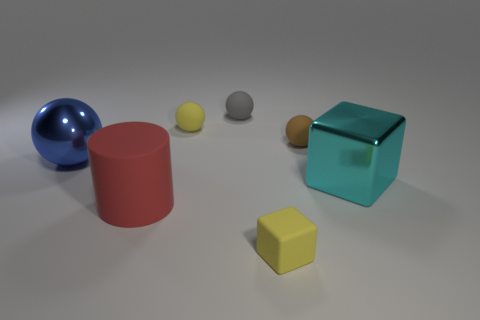Add 2 large yellow rubber blocks. How many objects exist? 9 Subtract all cylinders. How many objects are left? 6 Subtract 0 brown cylinders. How many objects are left? 7 Subtract all large red matte spheres. Subtract all big blue shiny spheres. How many objects are left? 6 Add 5 blue shiny spheres. How many blue shiny spheres are left? 6 Add 7 small brown rubber cubes. How many small brown rubber cubes exist? 7 